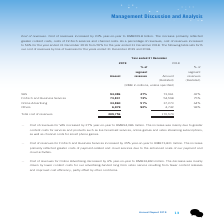According to Tencent's financial document, What was the year-on-year change in cost of revenues for VAS? According to the financial document, 27%. The relevant text states: "－ Cost of revenues for VAS increased by 27% year-on-year to RMB94,086 million. The increase was mainly due to greater..." Also, What was the year-on-year change in cost of revenues for FinTech and Business Services? According to the financial document, 35%. The relevant text states: "ues for FinTech and Business Services increased by 35% year-on-year to RMB73,831 million. The increase..." Also, What was the year-on-year change in cost of revenues for Online Advertising? According to the financial document, 6%. The relevant text states: "to 56% for the year ended 31 December 2019 from 55% for the year ended 31 December 2018. The following tabl..." Also, can you calculate: How much did the total cost of revenues increase by from 2018 to 2019? Based on the calculation: 209,756-170,574, the result is 39182 (in millions). This is based on the information: "Total cost of revenues 209,756 170,574 Total cost of revenues 209,756 170,574..." The key data points involved are: 170,574, 209,756. Also, can you calculate: How much is the combined 2019 cost of revenues for VAS and Fintech and Business Services? Based on the calculation: 94,086+73,831, the result is 167917 (in millions). This is based on the information: "FinTech and Business Services 73,831 73% 54,598 75% VAS 94,086 47% 73,961 42%..." The key data points involved are: 73,831, 94,086. Also, can you calculate: How much is the combined 2019 cost of revenues for Online Advertising and Others? Based on the calculation: 34,860+6,979, the result is 41839 (in millions). This is based on the information: "Online Advertising 34,860 51% 37,273 64% Others 6,979 92% 4,742 98%..." The key data points involved are: 34,860, 6,979. 